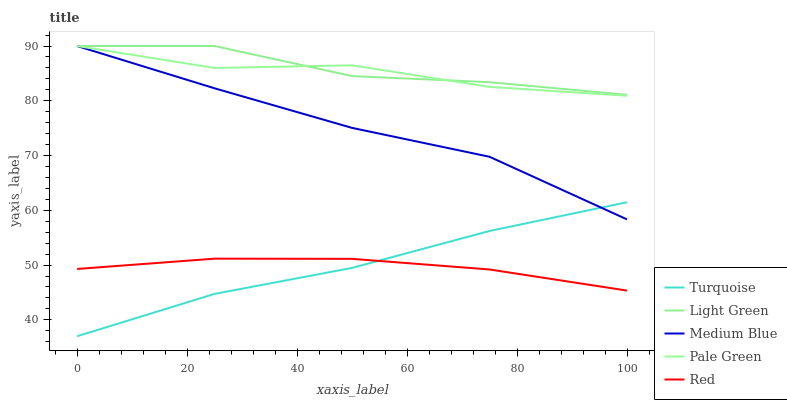Does Red have the minimum area under the curve?
Answer yes or no. Yes. Does Light Green have the maximum area under the curve?
Answer yes or no. Yes. Does Pale Green have the minimum area under the curve?
Answer yes or no. No. Does Pale Green have the maximum area under the curve?
Answer yes or no. No. Is Red the smoothest?
Answer yes or no. Yes. Is Pale Green the roughest?
Answer yes or no. Yes. Is Medium Blue the smoothest?
Answer yes or no. No. Is Medium Blue the roughest?
Answer yes or no. No. Does Turquoise have the lowest value?
Answer yes or no. Yes. Does Pale Green have the lowest value?
Answer yes or no. No. Does Light Green have the highest value?
Answer yes or no. Yes. Does Red have the highest value?
Answer yes or no. No. Is Red less than Light Green?
Answer yes or no. Yes. Is Pale Green greater than Turquoise?
Answer yes or no. Yes. Does Pale Green intersect Medium Blue?
Answer yes or no. Yes. Is Pale Green less than Medium Blue?
Answer yes or no. No. Is Pale Green greater than Medium Blue?
Answer yes or no. No. Does Red intersect Light Green?
Answer yes or no. No. 